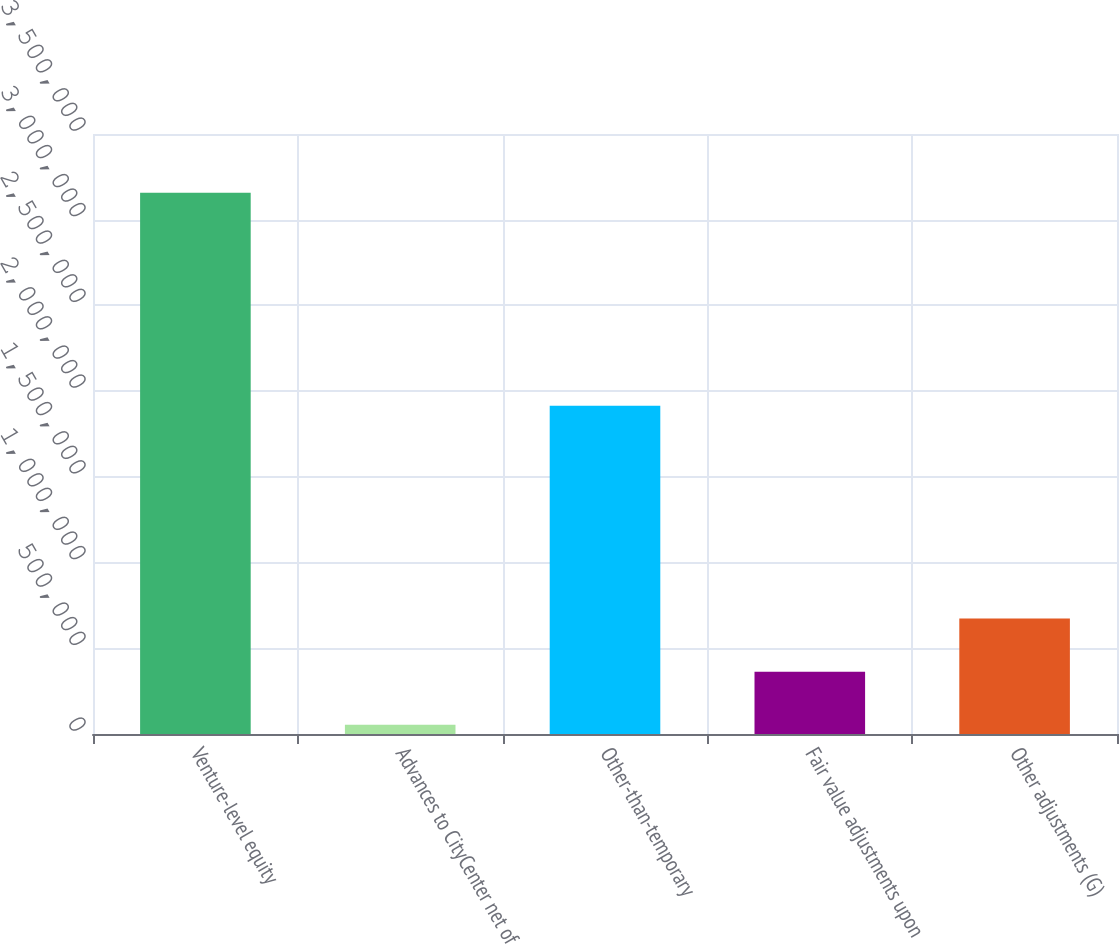Convert chart to OTSL. <chart><loc_0><loc_0><loc_500><loc_500><bar_chart><fcel>Venture-level equity<fcel>Advances to CityCenter net of<fcel>Other-than-temporary<fcel>Fair value adjustments upon<fcel>Other adjustments (G)<nl><fcel>3.15663e+06<fcel>53296<fcel>1.91515e+06<fcel>363630<fcel>673963<nl></chart> 